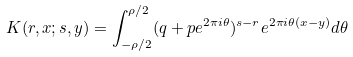<formula> <loc_0><loc_0><loc_500><loc_500>K ( r , x ; s , y ) = \int _ { - \rho / 2 } ^ { \rho / 2 } ( q + p e ^ { 2 \pi i \theta } ) ^ { s - r } e ^ { 2 \pi i \theta ( x - y ) } d \theta</formula> 